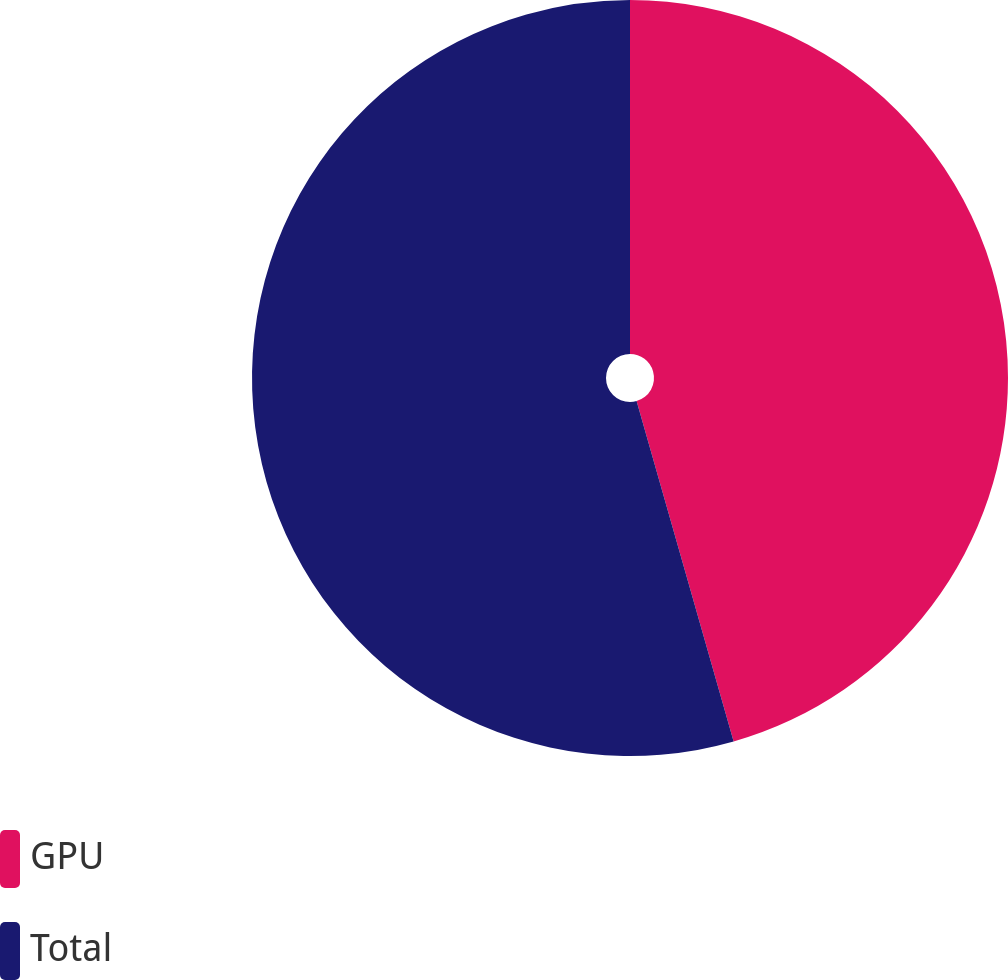Convert chart to OTSL. <chart><loc_0><loc_0><loc_500><loc_500><pie_chart><fcel>GPU<fcel>Total<nl><fcel>45.58%<fcel>54.42%<nl></chart> 